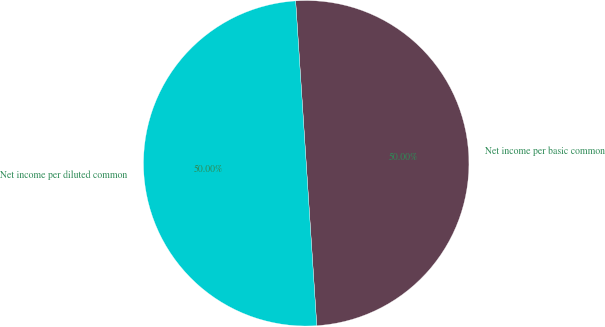<chart> <loc_0><loc_0><loc_500><loc_500><pie_chart><fcel>Net income per basic common<fcel>Net income per diluted common<nl><fcel>50.0%<fcel>50.0%<nl></chart> 